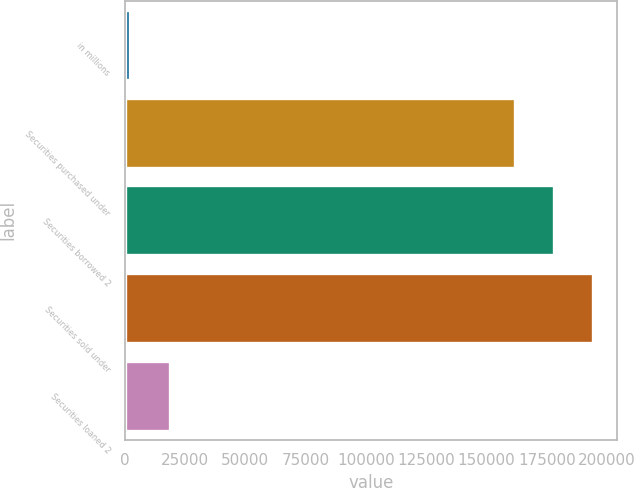Convert chart to OTSL. <chart><loc_0><loc_0><loc_500><loc_500><bar_chart><fcel>in millions<fcel>Securities purchased under<fcel>Securities borrowed 2<fcel>Securities sold under<fcel>Securities loaned 2<nl><fcel>2013<fcel>161732<fcel>178009<fcel>194286<fcel>18745<nl></chart> 